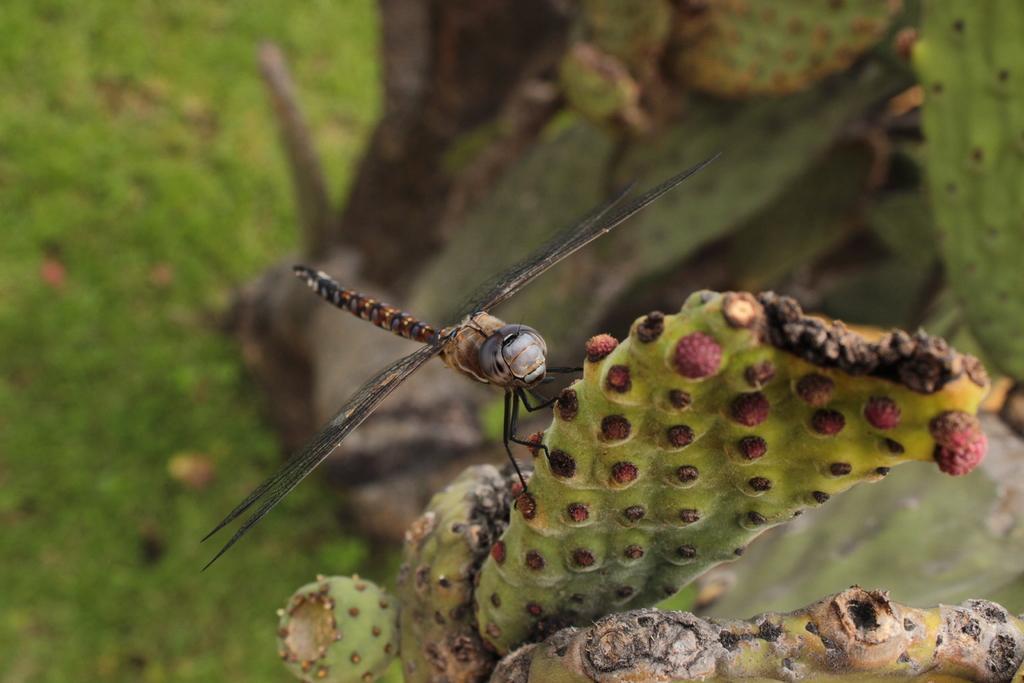How would you summarize this image in a sentence or two? There is a cactus plant. On that there is a dragonfly. In the background it is green and blurred. 